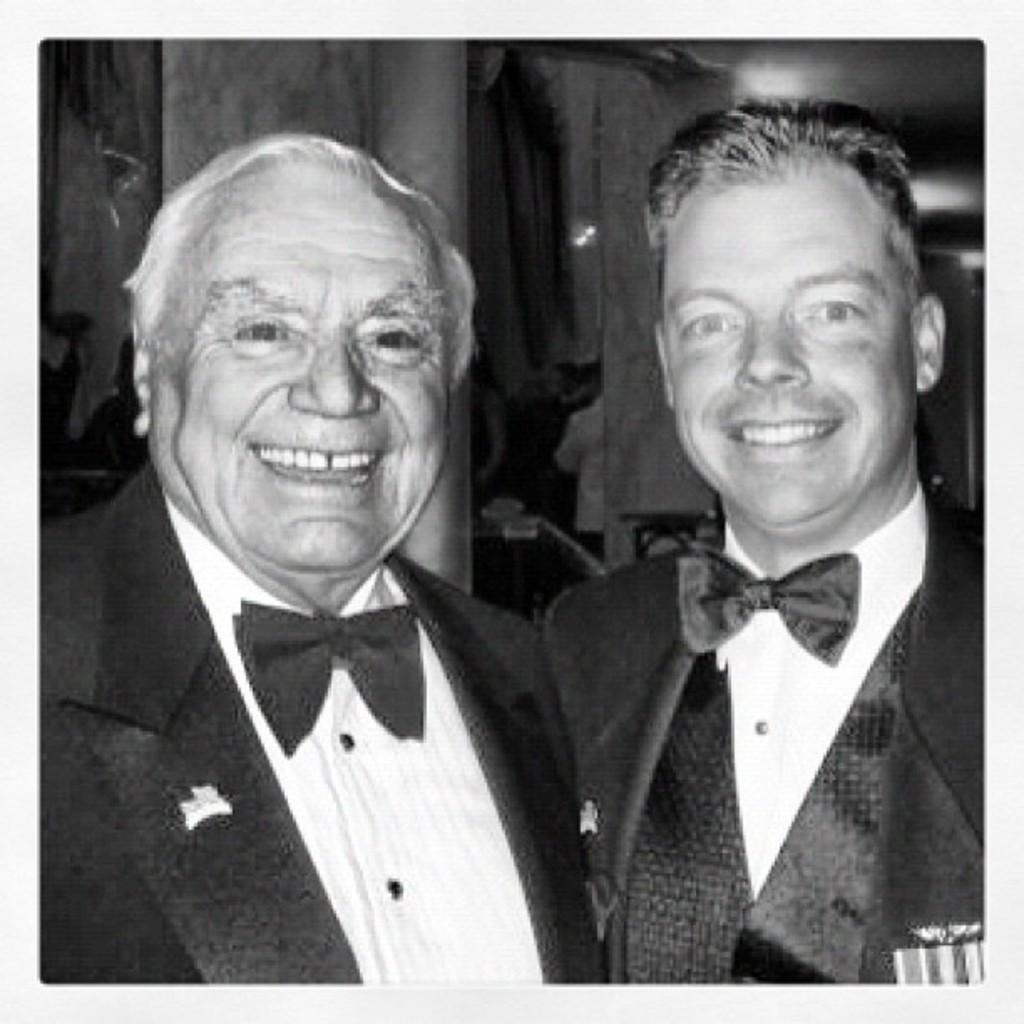What is the color scheme of the picture? The picture is black and white. How many people are in the image? There are two people in the picture. What are the people wearing in the image? Both people are wearing suits. What expressions do the people have in the image? Both people are smiling. What type of beef is being served at the event in the image? There is no event or beef present in the image; it features two people wearing suits and smiling. What chance does the person on the left have of winning the competition in the image? There is no competition or chance involved in the image; it simply shows two people wearing suits and smiling. 